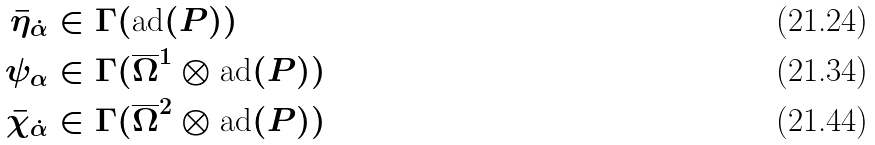Convert formula to latex. <formula><loc_0><loc_0><loc_500><loc_500>\bar { \eta } _ { \dot { \alpha } } & \in \Gamma ( \text {ad} ( P ) ) \\ \psi _ { \alpha } & \in \Gamma ( \overline { \Omega } ^ { 1 } \otimes \text {ad} ( P ) ) \\ \bar { \chi } _ { \dot { \alpha } } & \in \Gamma ( \overline { \Omega } ^ { 2 } \otimes \text {ad} ( P ) )</formula> 